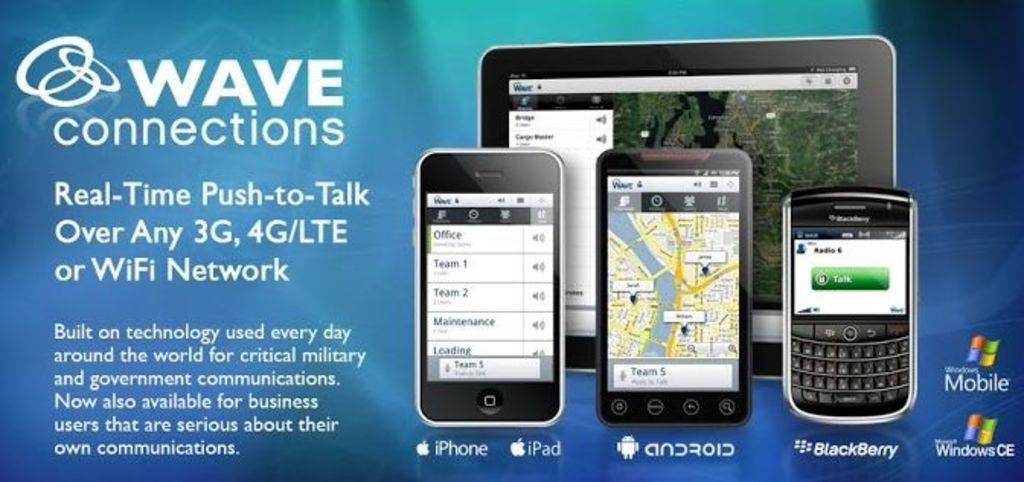<image>
Summarize the visual content of the image. A WAVE connections advertisement showing iPhone, iPad, android and Blackberry phones is pictured. 